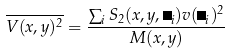Convert formula to latex. <formula><loc_0><loc_0><loc_500><loc_500>\overline { V ( x , y ) ^ { 2 } } = \frac { \sum _ { i } S _ { 2 } ( x , y , \Lambda _ { i } ) v ( \Lambda _ { i } ) ^ { 2 } } { M ( x , y ) }</formula> 